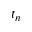Convert formula to latex. <formula><loc_0><loc_0><loc_500><loc_500>t _ { n }</formula> 